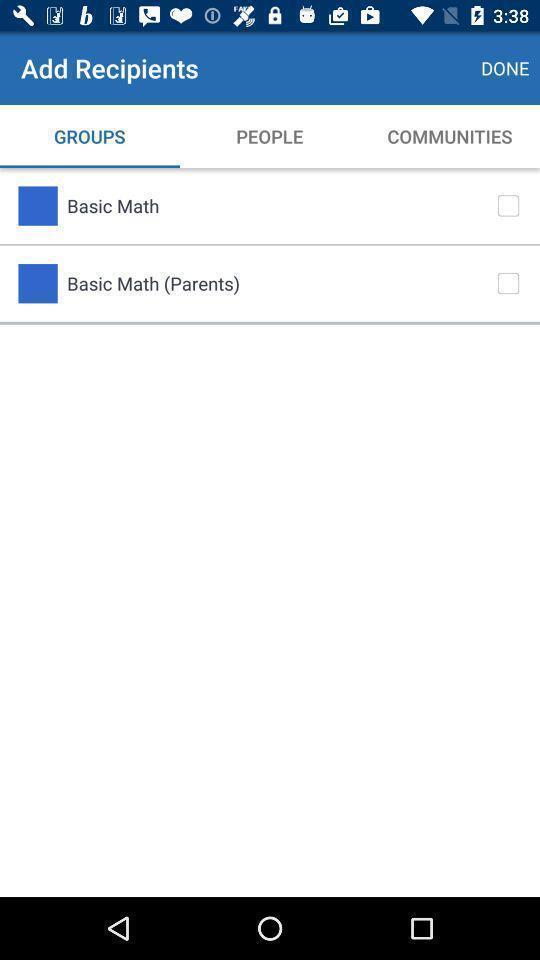Please provide a description for this image. Screen shows add recipients page with multiple options. 